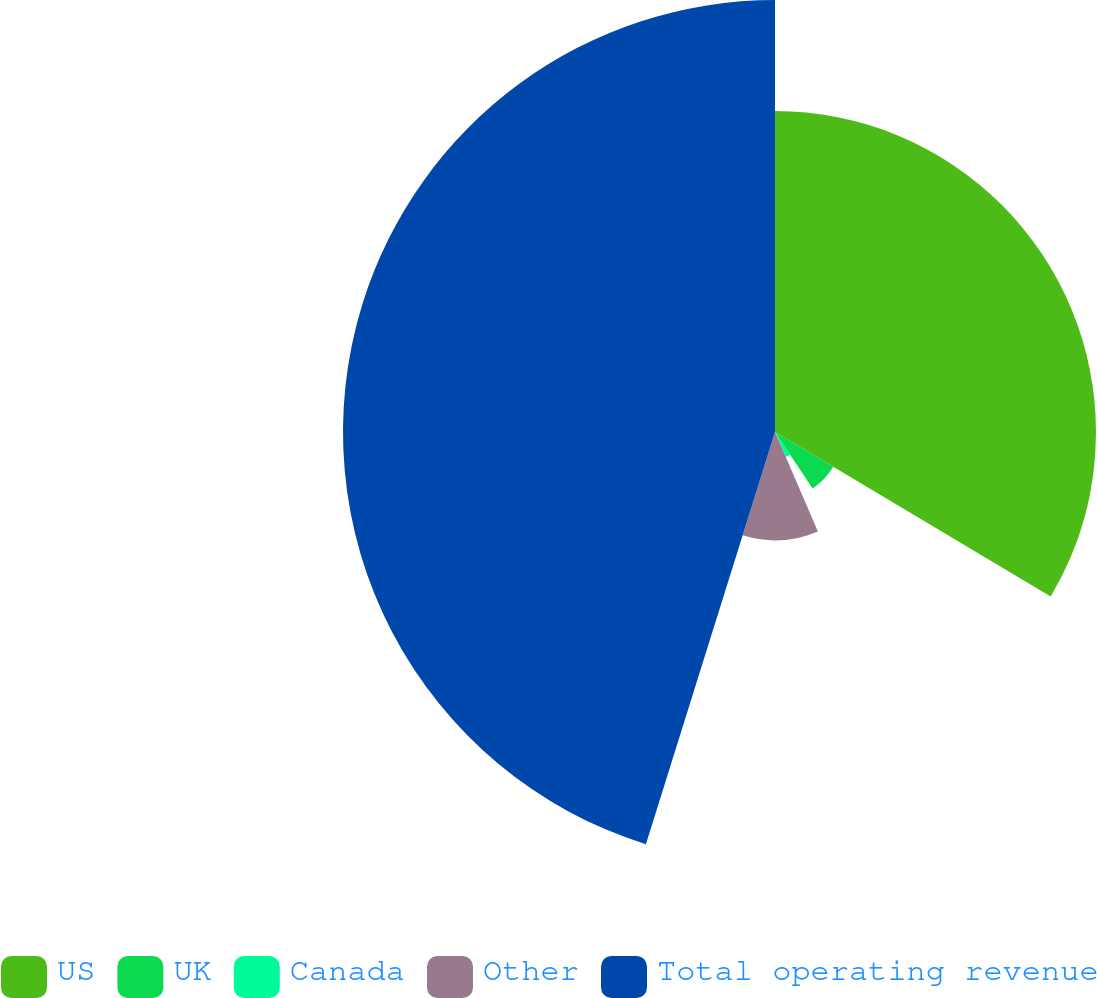Convert chart. <chart><loc_0><loc_0><loc_500><loc_500><pie_chart><fcel>US<fcel>UK<fcel>Canada<fcel>Other<fcel>Total operating revenue<nl><fcel>33.56%<fcel>7.09%<fcel>2.86%<fcel>11.32%<fcel>45.17%<nl></chart> 